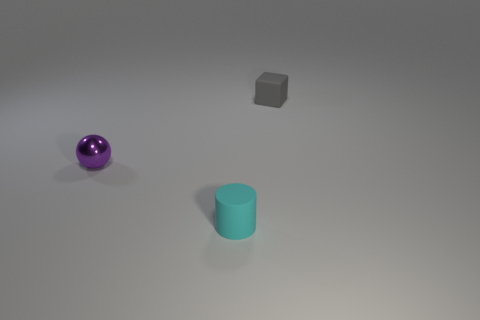What size is the gray rubber object that is right of the small purple metal object behind the rubber thing in front of the small matte block?
Your response must be concise. Small. Are there any matte blocks that are behind the tiny thing to the left of the tiny cyan thing?
Offer a very short reply. Yes. What number of gray blocks are in front of the small rubber thing on the right side of the small rubber object in front of the purple metallic object?
Your answer should be compact. 0. There is a thing that is on the right side of the purple metal ball and behind the tiny cyan rubber cylinder; what color is it?
Give a very brief answer. Gray. What number of cubes are tiny cyan rubber things or purple shiny things?
Provide a succinct answer. 0. The rubber cylinder that is the same size as the ball is what color?
Your answer should be very brief. Cyan. Are there any purple balls on the right side of the small matte object that is in front of the rubber object that is on the right side of the small cyan matte thing?
Offer a very short reply. No. What size is the rubber cylinder?
Offer a very short reply. Small. What number of things are tiny red matte objects or tiny gray objects?
Your answer should be very brief. 1. There is a block that is the same material as the cylinder; what color is it?
Ensure brevity in your answer.  Gray. 